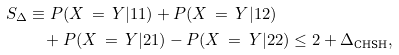Convert formula to latex. <formula><loc_0><loc_0><loc_500><loc_500>S _ { \Delta } & \equiv P ( X \, = \, Y | 1 1 ) + P ( X \, = \, Y | 1 2 ) \\ & \quad + P ( X \, = \, Y | 2 1 ) - P ( X \, = \, Y | 2 2 ) \leq 2 + \Delta _ { \text {CHSH} } ,</formula> 